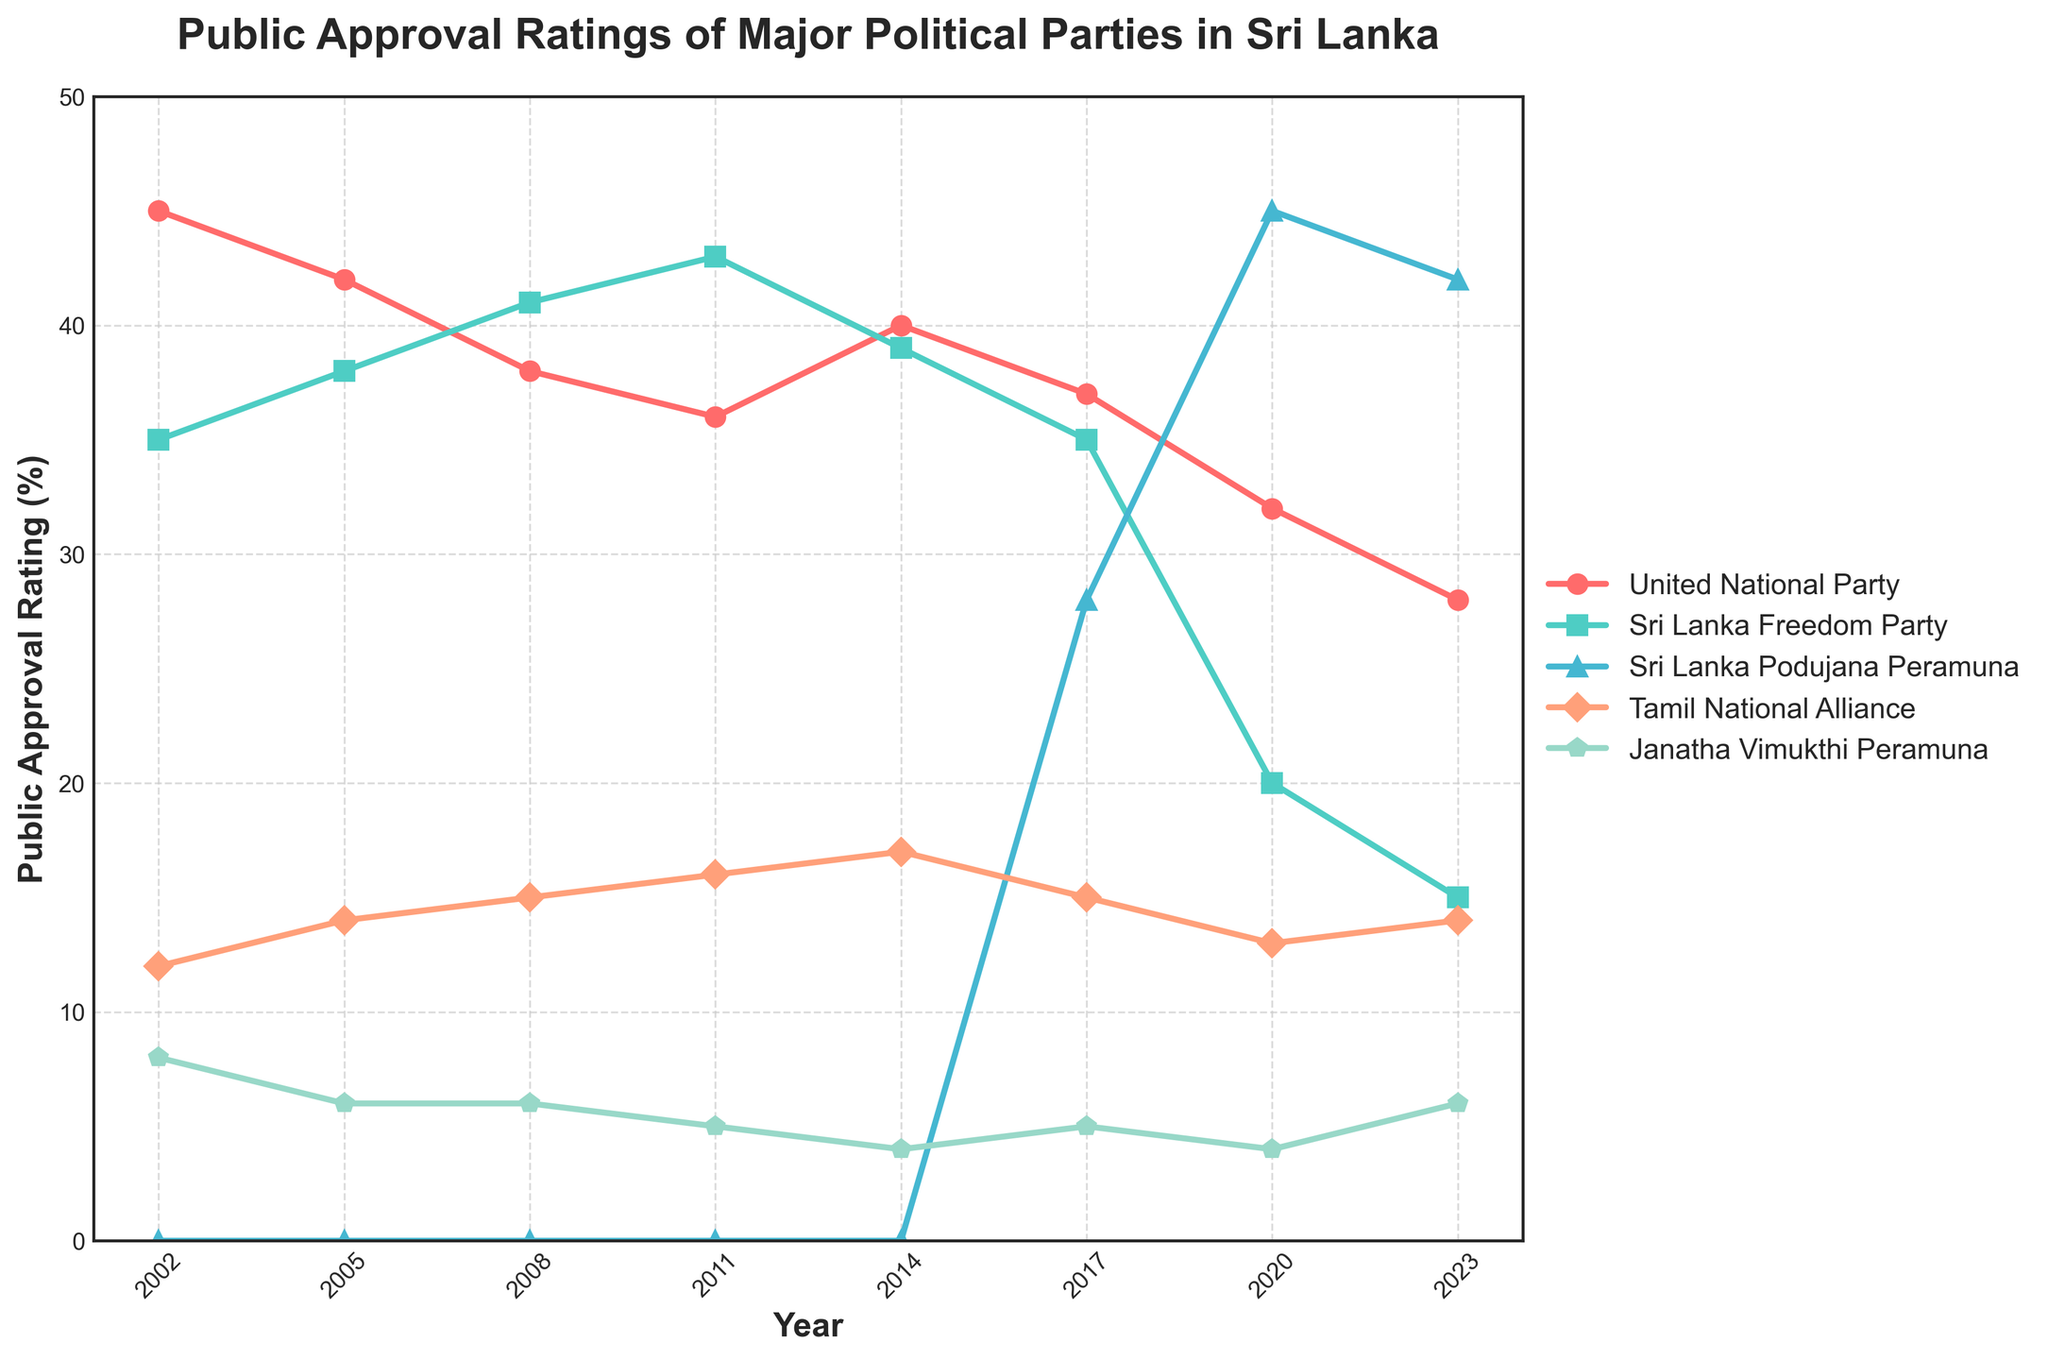What is the overall trend of the United National Party's approval rating over the two decades? The United National Party's (UNP) approval rating shows a general decline over time. In 2002, it started at 45%. By 2023, it had decreased to 28%. This indicates a downward trend.
Answer: Downward trend Which political party had the highest approval rating in 2020? In 2020, the Sri Lanka Podujana Peramuna (SLPP) had the highest approval rating at 45%. This can be observed by checking the corresponding data points on the line chart for each party in 2020.
Answer: Sri Lanka Podujana Peramuna (SLPP) Compare the approval ratings of the Janatha Vimukthi Peramuna in 2002 and 2023. Which year had a higher rating and by how much? In 2002, the Janatha Vimukthi Peramuna (JVP) had an approval rating of 8%. In 2023, their approval rating was 6%. Therefore, 2002 had a higher rating by 2 percentage points.
Answer: 2002, by 2 percentage points What is the approval rating trend for the Tamil National Alliance between 2002 and 2023? The Tamil National Alliance (TNA) shows a general upward trend in approval ratings. It started at 12% in 2002 and increased to 14% by 2023, with fluctuations in between.
Answer: Upward trend Which party's approval rating increased the most between 2014 and 2017? The Sri Lanka Podujana Peramuna (SLPP) had its approval rating increase from 0% in 2014 to 28% in 2017. This is the most significant increase among all parties during that period.
Answer: Sri Lanka Podujana Peramuna (SLPP) Between which years did the United National Party experience the most significant drop in approval rating? The United National Party (UNP) experienced the most significant drop between 2017 and 2020, where its approval rating went from 37% to 32%, a drop of 5 percentage points.
Answer: 2017 to 2020 How did the Sri Lanka Freedom Party's approval rating change from 2002 to 2023? The Sri Lanka Freedom Party (SLFP) had an approval rating of 35% in 2002 and it declined sharply to 15% by 2023. This indicates a substantial decrease over the two decades.
Answer: Decreased What is the average approval rating of the Janatha Vimukthi Peramuna over the two decades? To find the average, sum the approval ratings for JVP from all available years: 8 + 6 + 6 + 5 + 4 + 5 + 4 + 6 = 44. There are 8 data points, so the average approval rating is 44/8 = 5.5%.
Answer: 5.5% How does the trend of the United National Party compare to the Sri Lanka Podujana Peramuna from 2002 to 2023? The United National Party shows a downward trend, starting at 45% in 2002 and ending at 28% in 2023. In contrast, the Sri Lanka Podujana Peramuna appears for the first time in 2017 with 28% and rises to 42% by 2023, showing an upward trend.
Answer: UNP: downward, SLPP: upward 